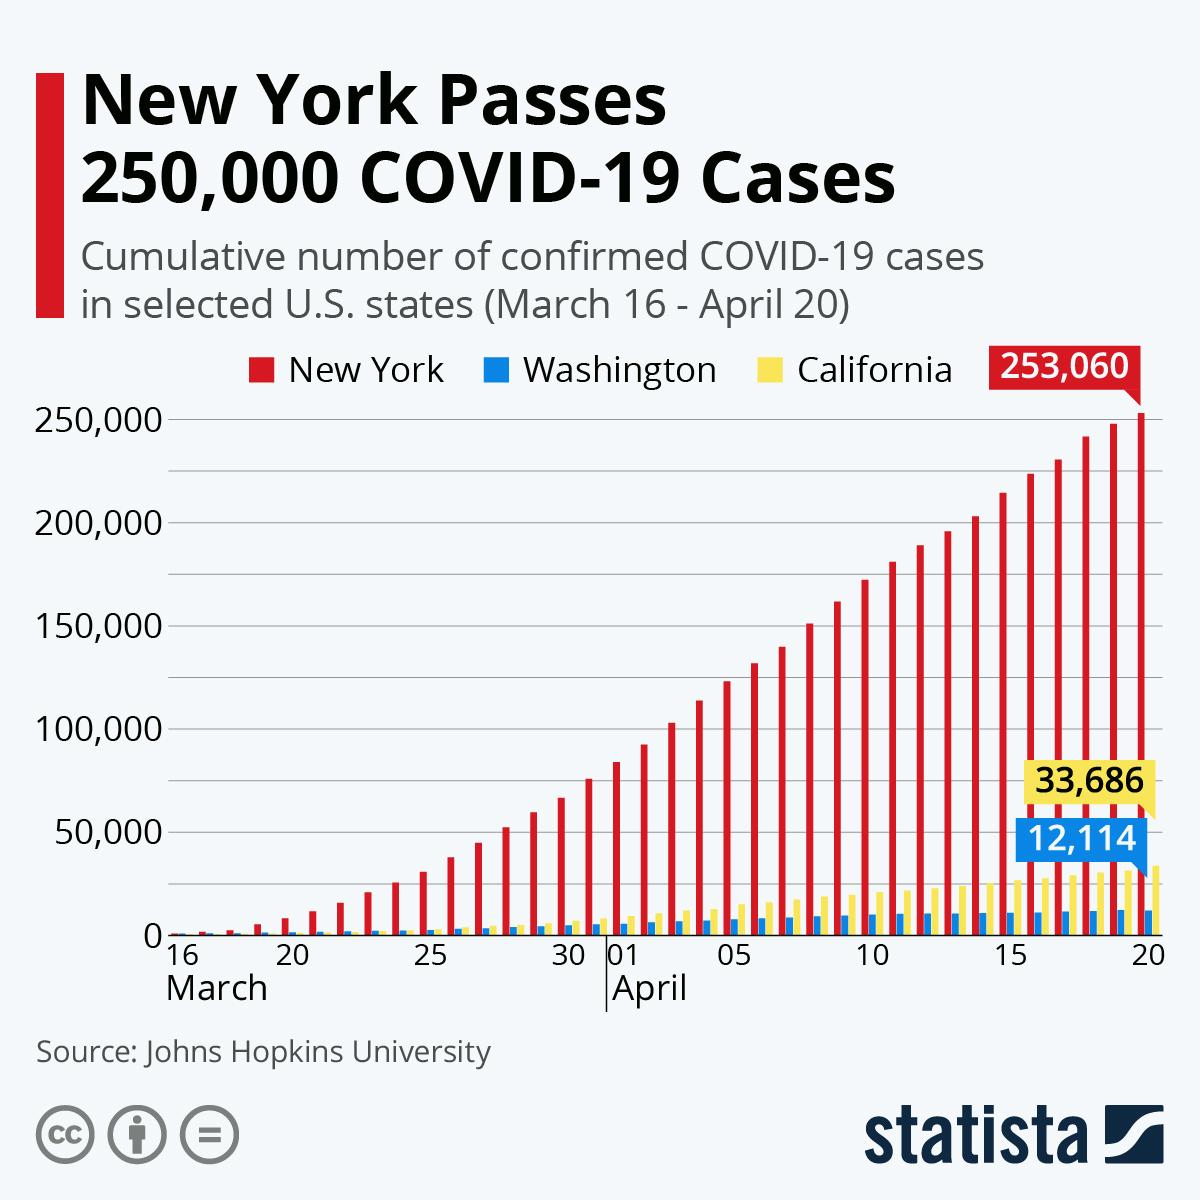Indicate a few pertinent items in this graphic. The highest recorded number of COVID-19 cases in California was 33,686. On April 14th, California surpassed the threshold of 25,000 COVID-19 cases. California experienced exponential growth in COVID-19 cases after New York. According to the color code given, New York is assigned the color green, yellow, blue, and red in that order. On April 14th, New York crossed the threshold of 200,000 confirmed cases of Covid-19. 